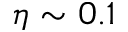Convert formula to latex. <formula><loc_0><loc_0><loc_500><loc_500>\eta \sim 0 . 1</formula> 